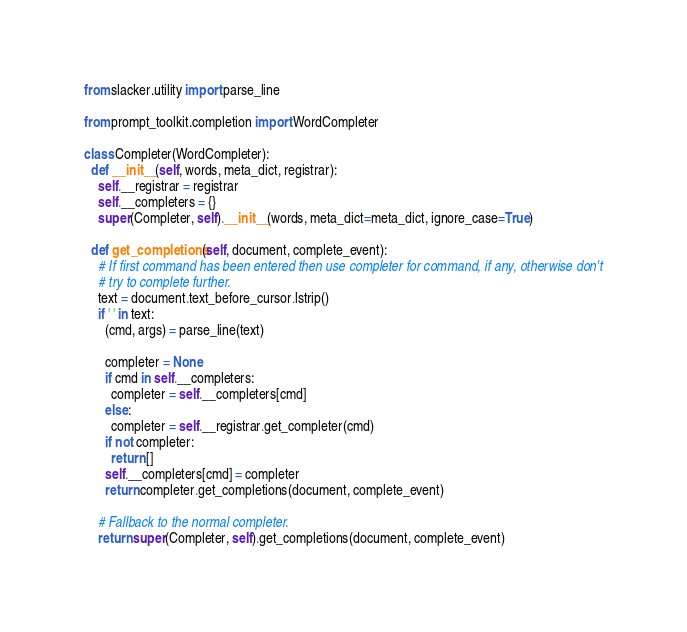<code> <loc_0><loc_0><loc_500><loc_500><_Python_>from slacker.utility import parse_line

from prompt_toolkit.completion import WordCompleter

class Completer(WordCompleter):
  def __init__(self, words, meta_dict, registrar):
    self.__registrar = registrar
    self.__completers = {}
    super(Completer, self).__init__(words, meta_dict=meta_dict, ignore_case=True)

  def get_completions(self, document, complete_event):
    # If first command has been entered then use completer for command, if any, otherwise don't
    # try to complete further.
    text = document.text_before_cursor.lstrip()
    if ' ' in text:
      (cmd, args) = parse_line(text)

      completer = None
      if cmd in self.__completers:
        completer = self.__completers[cmd]
      else:
        completer = self.__registrar.get_completer(cmd)
      if not completer:
        return []
      self.__completers[cmd] = completer
      return completer.get_completions(document, complete_event)

    # Fallback to the normal completer.
    return super(Completer, self).get_completions(document, complete_event)
</code> 